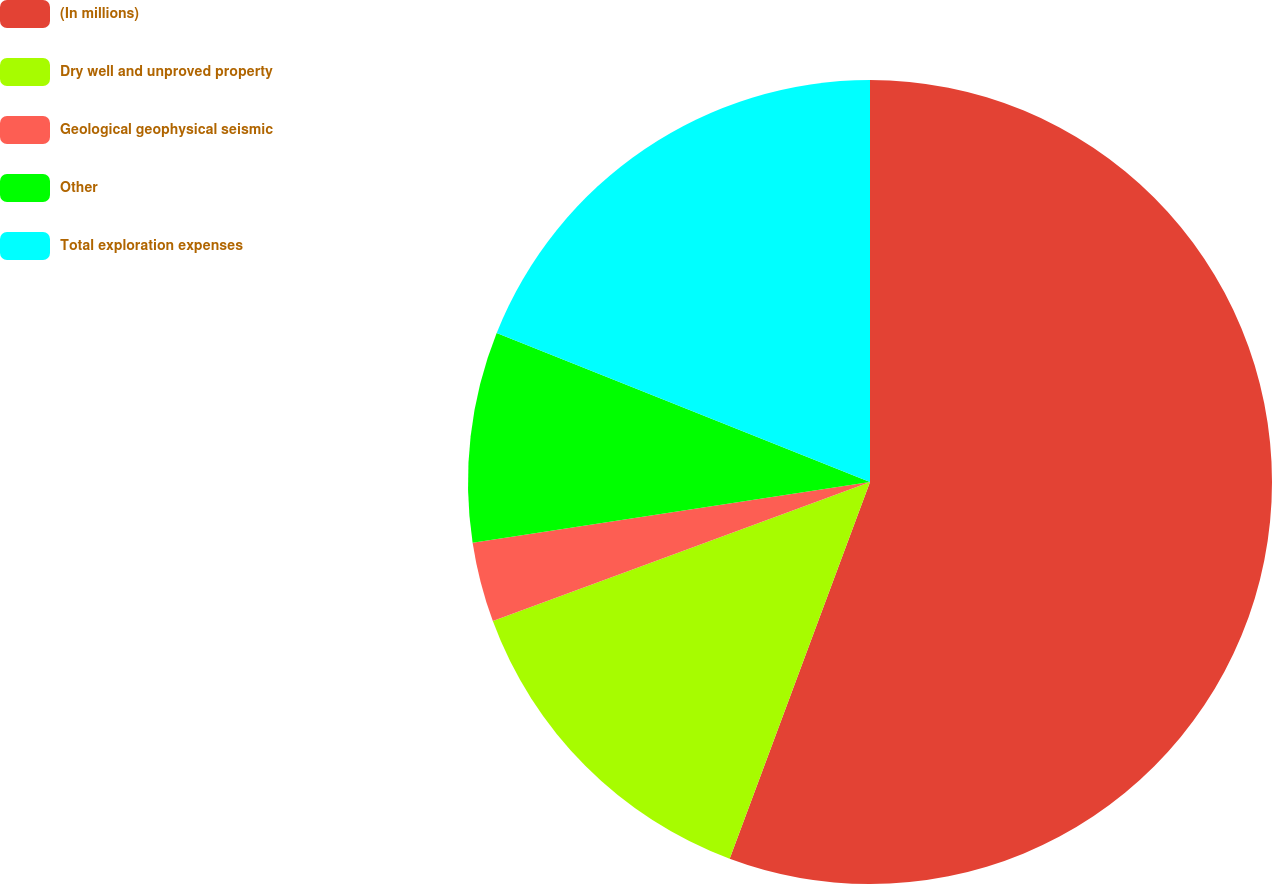Convert chart to OTSL. <chart><loc_0><loc_0><loc_500><loc_500><pie_chart><fcel>(In millions)<fcel>Dry well and unproved property<fcel>Geological geophysical seismic<fcel>Other<fcel>Total exploration expenses<nl><fcel>55.67%<fcel>13.7%<fcel>3.21%<fcel>8.46%<fcel>18.95%<nl></chart> 